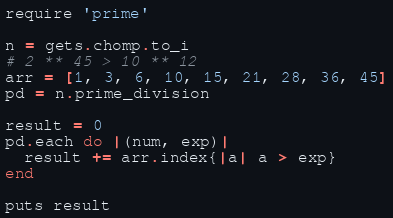<code> <loc_0><loc_0><loc_500><loc_500><_Ruby_>require 'prime'

n = gets.chomp.to_i
# 2 ** 45 > 10 ** 12
arr = [1, 3, 6, 10, 15, 21, 28, 36, 45]
pd = n.prime_division

result = 0
pd.each do |(num, exp)|
  result += arr.index{|a| a > exp}
end

puts result
</code> 